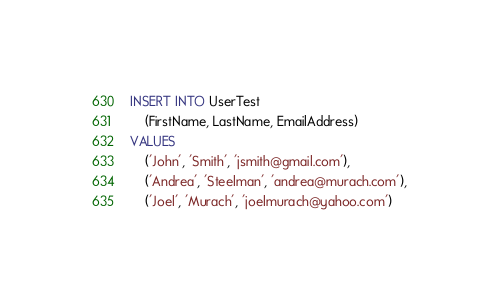Convert code to text. <code><loc_0><loc_0><loc_500><loc_500><_SQL_>INSERT INTO UserTest 
    (FirstName, LastName, EmailAddress)
VALUES 
    ('John', 'Smith', 'jsmith@gmail.com'), 
    ('Andrea', 'Steelman', 'andrea@murach.com'), 
    ('Joel', 'Murach', 'joelmurach@yahoo.com')
</code> 